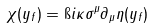Convert formula to latex. <formula><loc_0><loc_0><loc_500><loc_500>\chi ( y _ { f } ) = \i i \kappa \sigma ^ { \mu } \partial _ { \mu } \eta ( y _ { f } )</formula> 